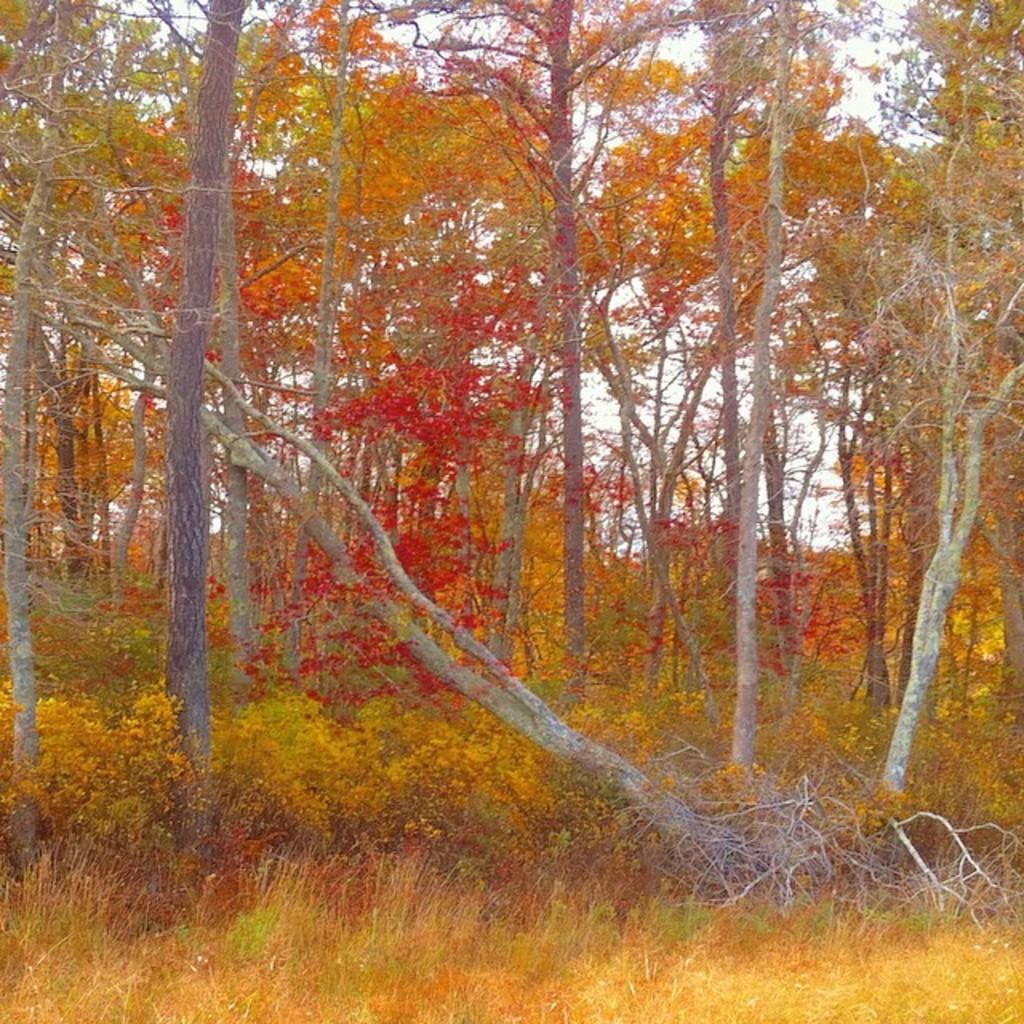What type of living organisms can be seen in the image? Plants and trees are visible in the image. What colors are present on the plants and trees in the image? The plants and trees have green, orange, and red colors. What is visible in the background of the image? The sky is visible in the background of the image. Can you tell me where the cork is located in the image? There is no cork present in the image. What type of gun can be seen in the image? There is no gun present in the image. 